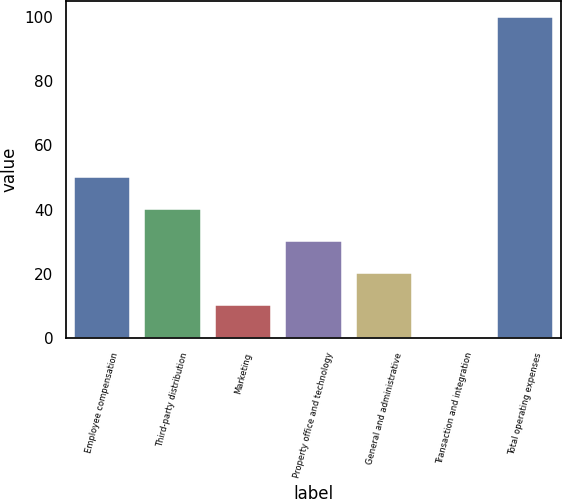<chart> <loc_0><loc_0><loc_500><loc_500><bar_chart><fcel>Employee compensation<fcel>Third-party distribution<fcel>Marketing<fcel>Property office and technology<fcel>General and administrative<fcel>Transaction and integration<fcel>Total operating expenses<nl><fcel>50.25<fcel>40.3<fcel>10.45<fcel>30.35<fcel>20.4<fcel>0.5<fcel>100<nl></chart> 